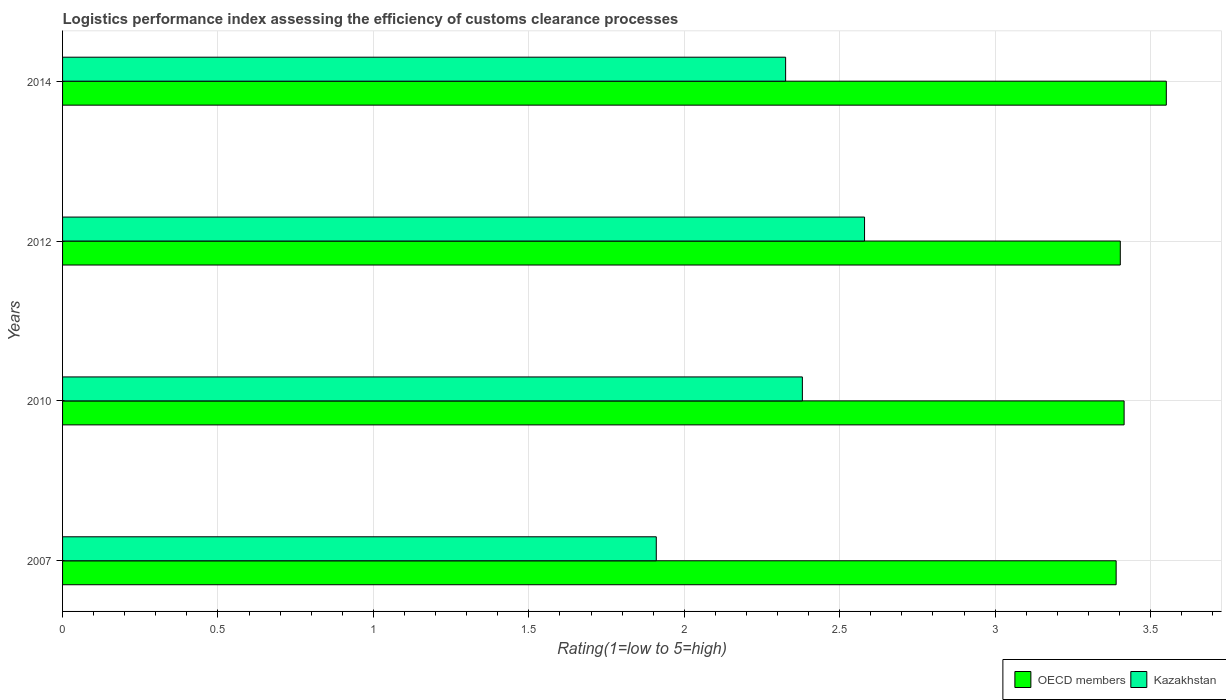How many groups of bars are there?
Offer a terse response. 4. Are the number of bars per tick equal to the number of legend labels?
Provide a succinct answer. Yes. Are the number of bars on each tick of the Y-axis equal?
Make the answer very short. Yes. How many bars are there on the 3rd tick from the bottom?
Provide a short and direct response. 2. What is the label of the 1st group of bars from the top?
Your response must be concise. 2014. What is the Logistic performance index in OECD members in 2010?
Ensure brevity in your answer.  3.42. Across all years, what is the maximum Logistic performance index in OECD members?
Offer a very short reply. 3.55. Across all years, what is the minimum Logistic performance index in OECD members?
Offer a terse response. 3.39. In which year was the Logistic performance index in Kazakhstan maximum?
Your answer should be very brief. 2012. What is the total Logistic performance index in Kazakhstan in the graph?
Offer a terse response. 9.2. What is the difference between the Logistic performance index in OECD members in 2007 and that in 2014?
Offer a very short reply. -0.16. What is the difference between the Logistic performance index in Kazakhstan in 2007 and the Logistic performance index in OECD members in 2012?
Your answer should be compact. -1.49. What is the average Logistic performance index in Kazakhstan per year?
Offer a terse response. 2.3. In the year 2014, what is the difference between the Logistic performance index in OECD members and Logistic performance index in Kazakhstan?
Provide a succinct answer. 1.22. In how many years, is the Logistic performance index in OECD members greater than 1.1 ?
Provide a short and direct response. 4. What is the ratio of the Logistic performance index in OECD members in 2010 to that in 2014?
Provide a succinct answer. 0.96. Is the Logistic performance index in OECD members in 2007 less than that in 2014?
Offer a very short reply. Yes. What is the difference between the highest and the second highest Logistic performance index in OECD members?
Provide a succinct answer. 0.14. What is the difference between the highest and the lowest Logistic performance index in OECD members?
Keep it short and to the point. 0.16. In how many years, is the Logistic performance index in OECD members greater than the average Logistic performance index in OECD members taken over all years?
Your response must be concise. 1. What does the 2nd bar from the top in 2012 represents?
Offer a very short reply. OECD members. How many bars are there?
Offer a very short reply. 8. Does the graph contain grids?
Offer a terse response. Yes. How many legend labels are there?
Your answer should be very brief. 2. How are the legend labels stacked?
Your answer should be very brief. Horizontal. What is the title of the graph?
Offer a very short reply. Logistics performance index assessing the efficiency of customs clearance processes. Does "Mauritania" appear as one of the legend labels in the graph?
Make the answer very short. No. What is the label or title of the X-axis?
Ensure brevity in your answer.  Rating(1=low to 5=high). What is the Rating(1=low to 5=high) in OECD members in 2007?
Your answer should be compact. 3.39. What is the Rating(1=low to 5=high) in Kazakhstan in 2007?
Give a very brief answer. 1.91. What is the Rating(1=low to 5=high) in OECD members in 2010?
Your answer should be very brief. 3.42. What is the Rating(1=low to 5=high) of Kazakhstan in 2010?
Offer a terse response. 2.38. What is the Rating(1=low to 5=high) in OECD members in 2012?
Your response must be concise. 3.4. What is the Rating(1=low to 5=high) of Kazakhstan in 2012?
Your response must be concise. 2.58. What is the Rating(1=low to 5=high) of OECD members in 2014?
Ensure brevity in your answer.  3.55. What is the Rating(1=low to 5=high) in Kazakhstan in 2014?
Provide a succinct answer. 2.33. Across all years, what is the maximum Rating(1=low to 5=high) in OECD members?
Offer a terse response. 3.55. Across all years, what is the maximum Rating(1=low to 5=high) in Kazakhstan?
Your answer should be compact. 2.58. Across all years, what is the minimum Rating(1=low to 5=high) in OECD members?
Your response must be concise. 3.39. Across all years, what is the minimum Rating(1=low to 5=high) in Kazakhstan?
Offer a very short reply. 1.91. What is the total Rating(1=low to 5=high) of OECD members in the graph?
Ensure brevity in your answer.  13.76. What is the total Rating(1=low to 5=high) in Kazakhstan in the graph?
Provide a short and direct response. 9.2. What is the difference between the Rating(1=low to 5=high) in OECD members in 2007 and that in 2010?
Provide a short and direct response. -0.03. What is the difference between the Rating(1=low to 5=high) of Kazakhstan in 2007 and that in 2010?
Your answer should be compact. -0.47. What is the difference between the Rating(1=low to 5=high) of OECD members in 2007 and that in 2012?
Provide a succinct answer. -0.01. What is the difference between the Rating(1=low to 5=high) of Kazakhstan in 2007 and that in 2012?
Offer a very short reply. -0.67. What is the difference between the Rating(1=low to 5=high) of OECD members in 2007 and that in 2014?
Your answer should be very brief. -0.16. What is the difference between the Rating(1=low to 5=high) of Kazakhstan in 2007 and that in 2014?
Your response must be concise. -0.42. What is the difference between the Rating(1=low to 5=high) of OECD members in 2010 and that in 2012?
Provide a short and direct response. 0.01. What is the difference between the Rating(1=low to 5=high) of Kazakhstan in 2010 and that in 2012?
Your response must be concise. -0.2. What is the difference between the Rating(1=low to 5=high) of OECD members in 2010 and that in 2014?
Ensure brevity in your answer.  -0.14. What is the difference between the Rating(1=low to 5=high) in Kazakhstan in 2010 and that in 2014?
Provide a short and direct response. 0.05. What is the difference between the Rating(1=low to 5=high) in OECD members in 2012 and that in 2014?
Your response must be concise. -0.15. What is the difference between the Rating(1=low to 5=high) of Kazakhstan in 2012 and that in 2014?
Your response must be concise. 0.25. What is the difference between the Rating(1=low to 5=high) in OECD members in 2007 and the Rating(1=low to 5=high) in Kazakhstan in 2010?
Ensure brevity in your answer.  1.01. What is the difference between the Rating(1=low to 5=high) of OECD members in 2007 and the Rating(1=low to 5=high) of Kazakhstan in 2012?
Offer a terse response. 0.81. What is the difference between the Rating(1=low to 5=high) of OECD members in 2007 and the Rating(1=low to 5=high) of Kazakhstan in 2014?
Provide a short and direct response. 1.06. What is the difference between the Rating(1=low to 5=high) in OECD members in 2010 and the Rating(1=low to 5=high) in Kazakhstan in 2012?
Offer a terse response. 0.83. What is the difference between the Rating(1=low to 5=high) of OECD members in 2010 and the Rating(1=low to 5=high) of Kazakhstan in 2014?
Your answer should be compact. 1.09. What is the difference between the Rating(1=low to 5=high) of OECD members in 2012 and the Rating(1=low to 5=high) of Kazakhstan in 2014?
Keep it short and to the point. 1.08. What is the average Rating(1=low to 5=high) of OECD members per year?
Provide a succinct answer. 3.44. What is the average Rating(1=low to 5=high) of Kazakhstan per year?
Offer a terse response. 2.3. In the year 2007, what is the difference between the Rating(1=low to 5=high) in OECD members and Rating(1=low to 5=high) in Kazakhstan?
Make the answer very short. 1.48. In the year 2010, what is the difference between the Rating(1=low to 5=high) of OECD members and Rating(1=low to 5=high) of Kazakhstan?
Make the answer very short. 1.03. In the year 2012, what is the difference between the Rating(1=low to 5=high) of OECD members and Rating(1=low to 5=high) of Kazakhstan?
Your answer should be very brief. 0.82. In the year 2014, what is the difference between the Rating(1=low to 5=high) in OECD members and Rating(1=low to 5=high) in Kazakhstan?
Keep it short and to the point. 1.22. What is the ratio of the Rating(1=low to 5=high) of Kazakhstan in 2007 to that in 2010?
Give a very brief answer. 0.8. What is the ratio of the Rating(1=low to 5=high) of Kazakhstan in 2007 to that in 2012?
Ensure brevity in your answer.  0.74. What is the ratio of the Rating(1=low to 5=high) in OECD members in 2007 to that in 2014?
Offer a very short reply. 0.95. What is the ratio of the Rating(1=low to 5=high) of Kazakhstan in 2007 to that in 2014?
Your answer should be compact. 0.82. What is the ratio of the Rating(1=low to 5=high) in OECD members in 2010 to that in 2012?
Offer a terse response. 1. What is the ratio of the Rating(1=low to 5=high) of Kazakhstan in 2010 to that in 2012?
Make the answer very short. 0.92. What is the ratio of the Rating(1=low to 5=high) of OECD members in 2010 to that in 2014?
Provide a short and direct response. 0.96. What is the ratio of the Rating(1=low to 5=high) in Kazakhstan in 2010 to that in 2014?
Ensure brevity in your answer.  1.02. What is the ratio of the Rating(1=low to 5=high) in Kazakhstan in 2012 to that in 2014?
Your answer should be very brief. 1.11. What is the difference between the highest and the second highest Rating(1=low to 5=high) of OECD members?
Your answer should be compact. 0.14. What is the difference between the highest and the second highest Rating(1=low to 5=high) in Kazakhstan?
Make the answer very short. 0.2. What is the difference between the highest and the lowest Rating(1=low to 5=high) in OECD members?
Ensure brevity in your answer.  0.16. What is the difference between the highest and the lowest Rating(1=low to 5=high) of Kazakhstan?
Provide a succinct answer. 0.67. 